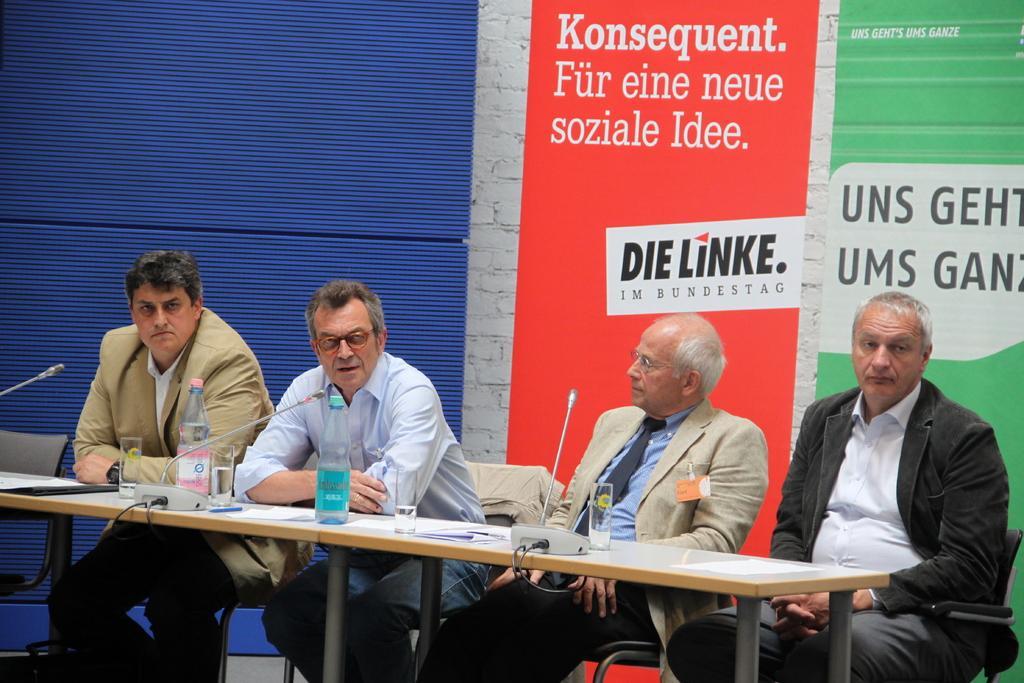In one or two sentences, can you explain what this image depicts? In the middle of the image four people sitting on the chair. Behind them there are some banners. Bottom left side of the image there is a table, On the table there is a water bottle and glass and microphones. 